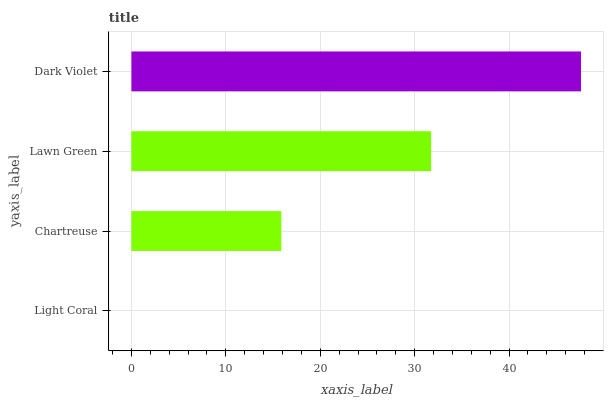Is Light Coral the minimum?
Answer yes or no. Yes. Is Dark Violet the maximum?
Answer yes or no. Yes. Is Chartreuse the minimum?
Answer yes or no. No. Is Chartreuse the maximum?
Answer yes or no. No. Is Chartreuse greater than Light Coral?
Answer yes or no. Yes. Is Light Coral less than Chartreuse?
Answer yes or no. Yes. Is Light Coral greater than Chartreuse?
Answer yes or no. No. Is Chartreuse less than Light Coral?
Answer yes or no. No. Is Lawn Green the high median?
Answer yes or no. Yes. Is Chartreuse the low median?
Answer yes or no. Yes. Is Light Coral the high median?
Answer yes or no. No. Is Dark Violet the low median?
Answer yes or no. No. 